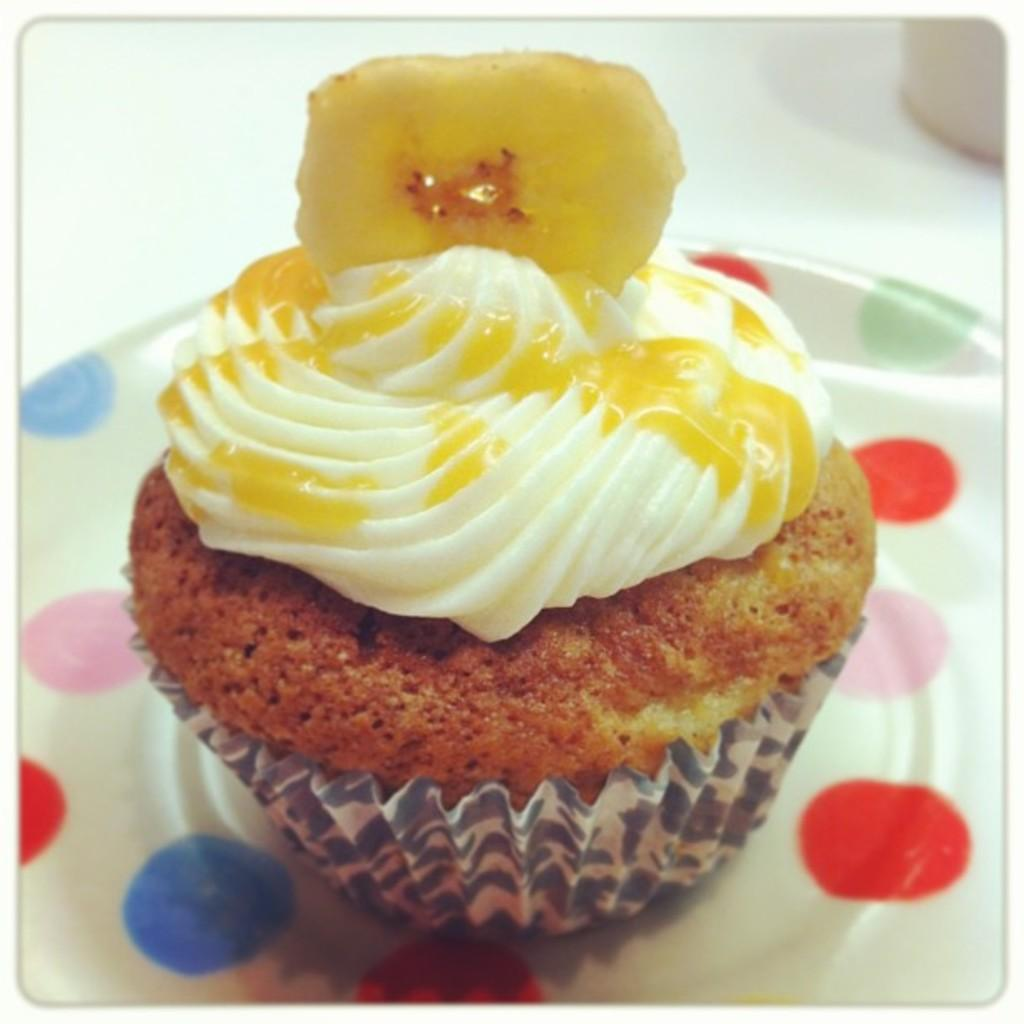What type of dessert is featured in the image? There is a chocolate cupcake in the image. How is the cupcake presented? The cupcake is placed on a white plate. What is the color of the background in the image? There is a white background in the image. What selection of minute-sized items can be seen in the image? There are no minute-sized items present in the image; it features a chocolate cupcake on a white plate with a white background. 